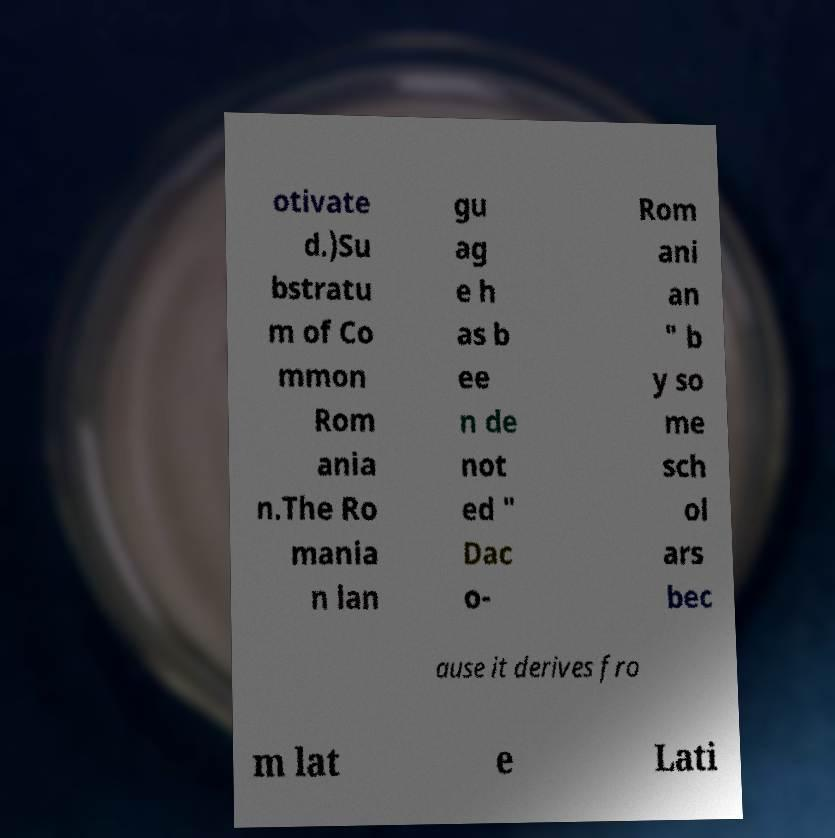Please identify and transcribe the text found in this image. otivate d.)Su bstratu m of Co mmon Rom ania n.The Ro mania n lan gu ag e h as b ee n de not ed " Dac o- Rom ani an " b y so me sch ol ars bec ause it derives fro m lat e Lati 